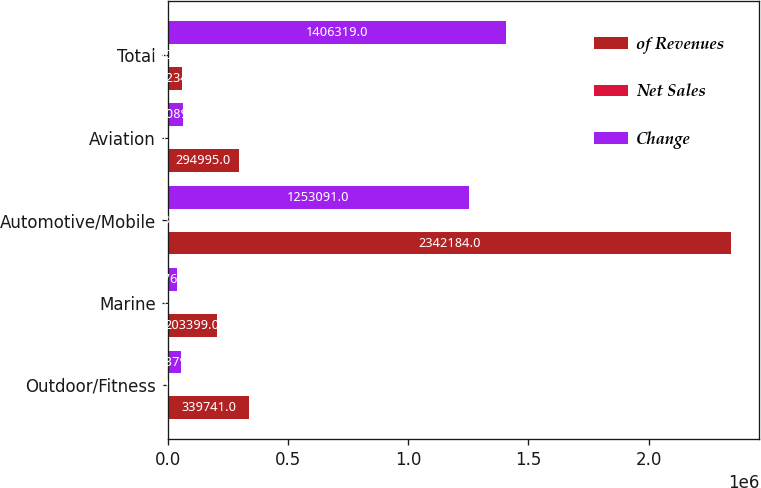Convert chart. <chart><loc_0><loc_0><loc_500><loc_500><stacked_bar_chart><ecel><fcel>Outdoor/Fitness<fcel>Marine<fcel>Automotive/Mobile<fcel>Aviation<fcel>Total<nl><fcel>of Revenues<fcel>339741<fcel>203399<fcel>2.34218e+06<fcel>294995<fcel>58234<nl><fcel>Net Sales<fcel>10.7<fcel>6.4<fcel>73.6<fcel>9.3<fcel>100<nl><fcel>Change<fcel>54379<fcel>36760<fcel>1.25309e+06<fcel>62089<fcel>1.40632e+06<nl></chart> 